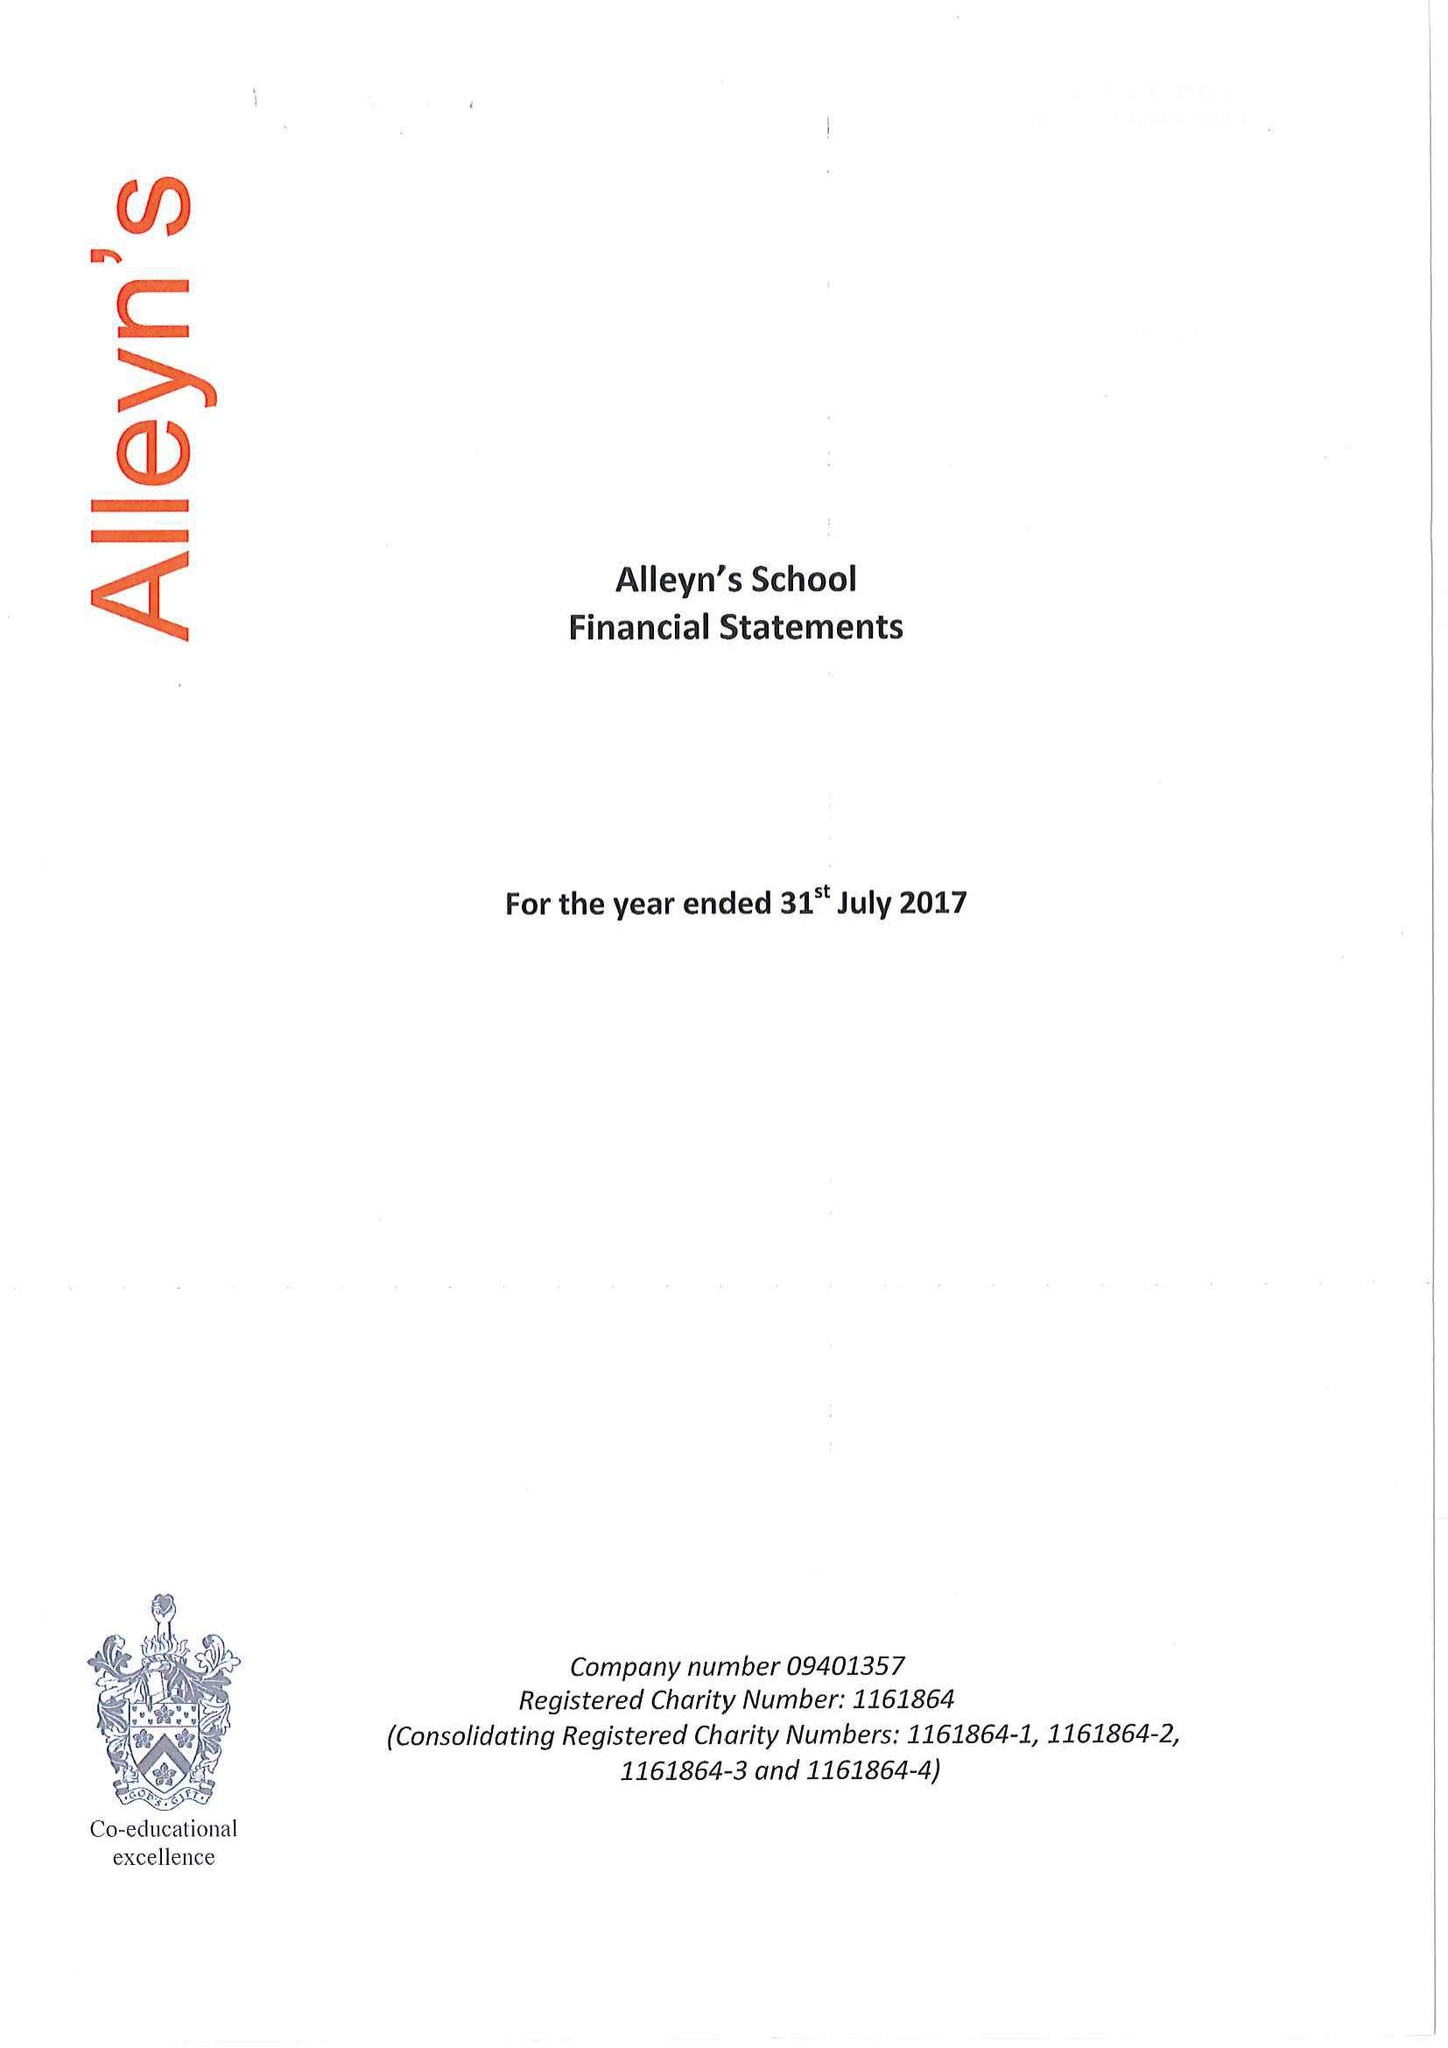What is the value for the charity_name?
Answer the question using a single word or phrase. Alleyn's School 